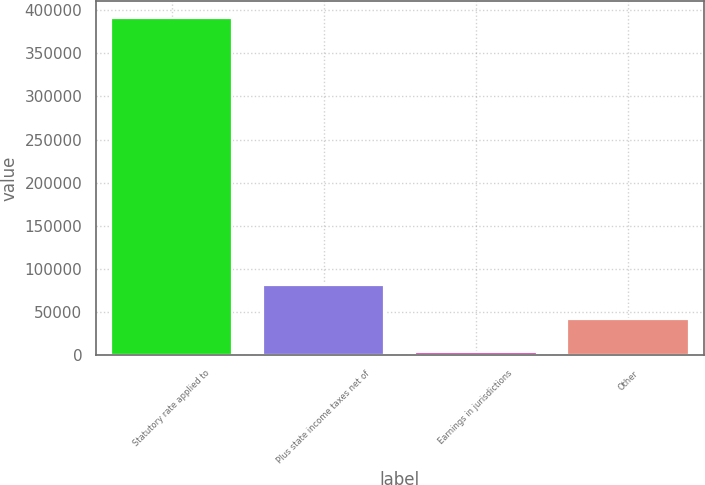<chart> <loc_0><loc_0><loc_500><loc_500><bar_chart><fcel>Statutory rate applied to<fcel>Plus state income taxes net of<fcel>Earnings in jurisdictions<fcel>Other<nl><fcel>391209<fcel>81004.2<fcel>3453<fcel>42228.6<nl></chart> 